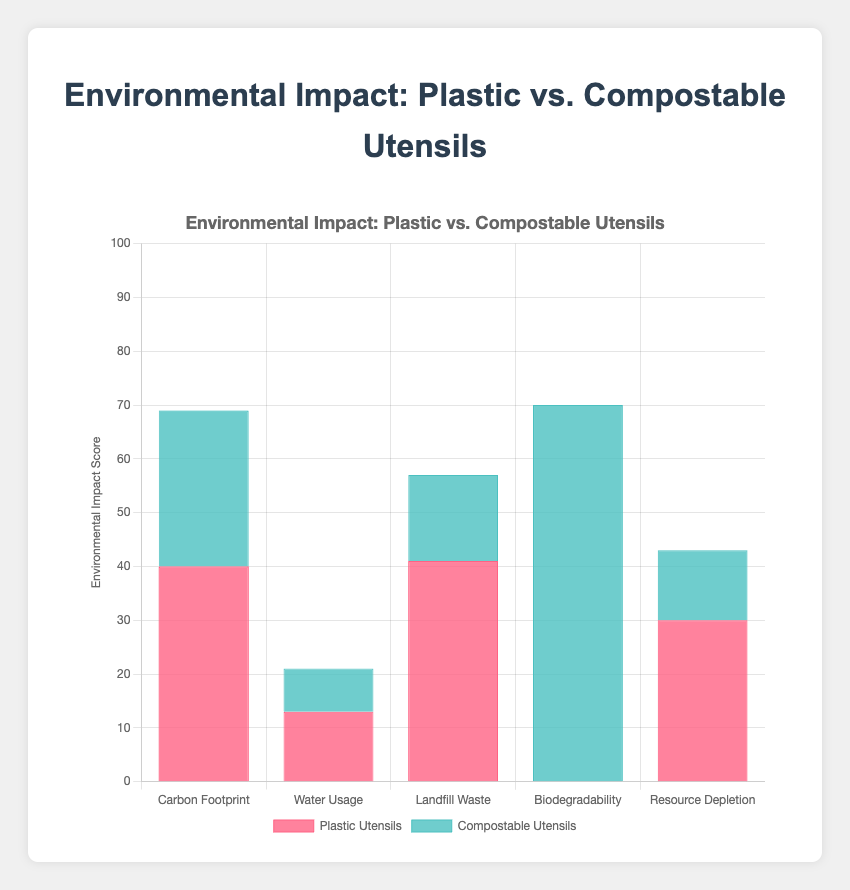What is the total Carbon Footprint for Plastic Utensils? To find the total Carbon Footprint, add Production (20), Transport (5), and Disposal (15) for Plastic Utensils. So, 20 + 5 + 15 = 40
Answer: 40 Which category has the highest environmental impact for Compostable Utensils? Look at the stacked bars for each category for Compostable Utensils. Biodegradability appears to have the highest value at 70 (20 for Production + 50 for Disposal)
Answer: Biodegradability How much more Landfill Waste is created by Plastic Utensils compared to Compostable Utensils? Plastic Utensils have a total Landfill Waste of 41 (10 Production + 1 Transport + 30 Disposal) while Compostable Utensils have 16 (5 Production + 1 Transport + 10 Disposal). The difference is 41 - 16 = 25
Answer: 25 What is the combined environmental impact score for Water Usage for both Plastic and Compostable Utensils? Plastic Water Usage: Production (10) + Transport (2) + Disposal (1) = 13. Compostable Water Usage: Production (5) + Transport (2) + Disposal (1) = 8. Combined: 13 + 8 = 21
Answer: 21 In which categories do Compostable Utensils have lower scores than Plastic Utensils? Compare the bar heights for each category. Compostable Utensils have lower scores in Carbon Footprint, Water Usage, Landfill Waste, and Resource Depletion
Answer: Carbon Footprint, Water Usage, Landfill Waste, Resource Depletion What is the difference in the Biodegradability category between Plastic and Compostable Utensils? Plastic Utensils have 0 in all parts of Biodegradability. Compostable Utensils have 20 for Production and 50 for Disposal, totaling 70. The difference is 70 - 0 = 70
Answer: 70 Which type of utensil has a higher total Resource Depletion score? Plastic Utensils: Production (25), Transport (5), Disposal (0) = 30. Compostable Utensils: Production (10), Transport (3), Disposal (0) = 13. So, Plastic Utensils have a higher total score
Answer: Plastic Utensils By how much does the Production impact weigh in the Carbon Footprint category for Plastic Utensils compared to Compostable Utensils? The Production impact for Carbon Footprint is 20 for Plastic and 15 for Compostable. The difference is 20 - 15 = 5
Answer: 5 